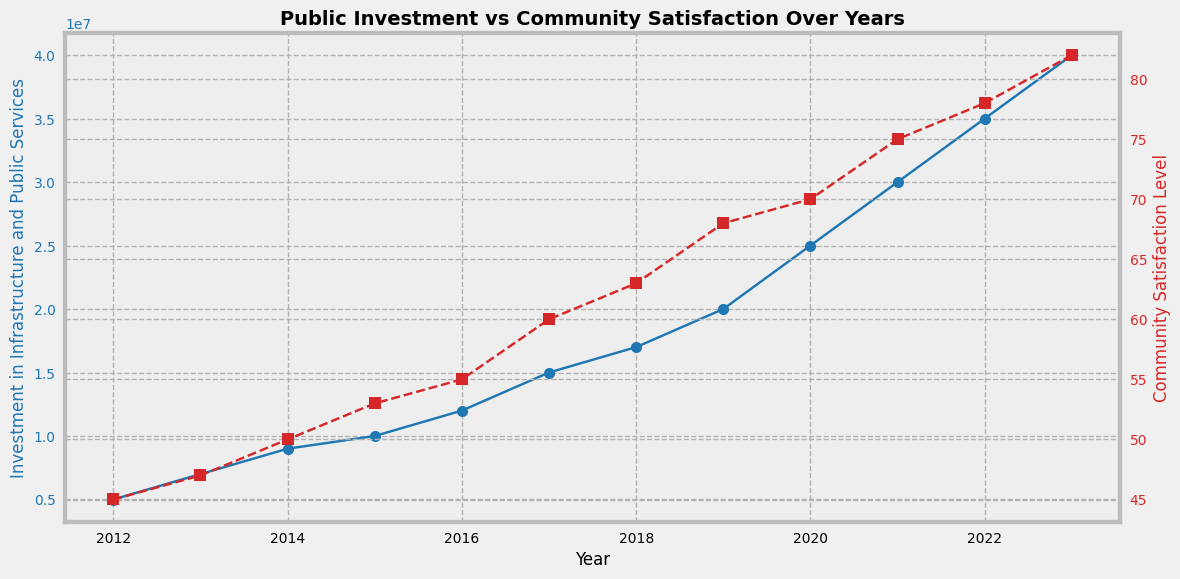What year had the highest Public Investment in Infrastructure and Public Services? Observe the plot. The highest point on the investment line occurs in 2023. Thus, 2023 had the highest public investment.
Answer: 2023 Is community satisfaction generally increasing from 2012 to 2023? The red line indicating community satisfaction shows an upward trend from 2012 to 2023 without any declines. This indicates a general increase in satisfaction over these years.
Answer: Yes By how much did the community satisfaction level increase from 2012 to 2023? In 2012, the satisfaction level was 45. In 2023, it was 82. The increase is calculated as 82 - 45 = 37.
Answer: 37 What is the average yearly investment from 2012 to 2023? Sum all investment values and divide by the number of years. (5000000 + 7000000 + 9000000 + 10000000 + 12000000 + 15000000 + 17000000 + 20000000 + 25000000 + 30000000 + 35000000 + 40000000) / 12 = 17,916,666.67.
Answer: 17,916,666.67 In which year did the community satisfaction level surpass 60 for the first time? Check the red line for the first time it crosses the 60 mark. This happens in 2017.
Answer: 2017 Which has a steeper slope, the investment line in 2017-2018 or the satisfaction line in 2021-2023? Calculate the slope for each: Investment slope (2017-2018) is (17000000 - 15000000) / (2018 - 2017) = 2000000. Satisfaction slope (2021-2023) is (82 - 75) / (2023 - 2021) = 3.5. Investment line has a steeper slope.
Answer: Investment line (2017-2018) How does the color of the lines help in distinguishing between investment and satisfaction? The investment line is in blue while the satisfaction line is in red. These distinct colors make it easy to differentiate between the two data sets.
Answer: Blue for investment, red for satisfaction What is the percentage increase in Public Investment from 2015 to 2020? The investment in 2015 was 10000000 and in 2020 it was 25000000. Percentage increase is ((25000000 - 10000000) / 10000000) * 100 = 150%.
Answer: 150% How much more was the Public Investment in 2022 compared to 2019? Investment in 2022 was 35000000 and in 2019 it was 20000000. The difference is 35000000 - 20000000 = 15000000.
Answer: 15000000 By what percentage did community satisfaction increase from 2020 to 2023? Satisfaction in 2020 was 70, and in 2023 it was 82. Percentage increase is ((82 - 70) / 70) * 100 = 17.14%.
Answer: 17.14% 